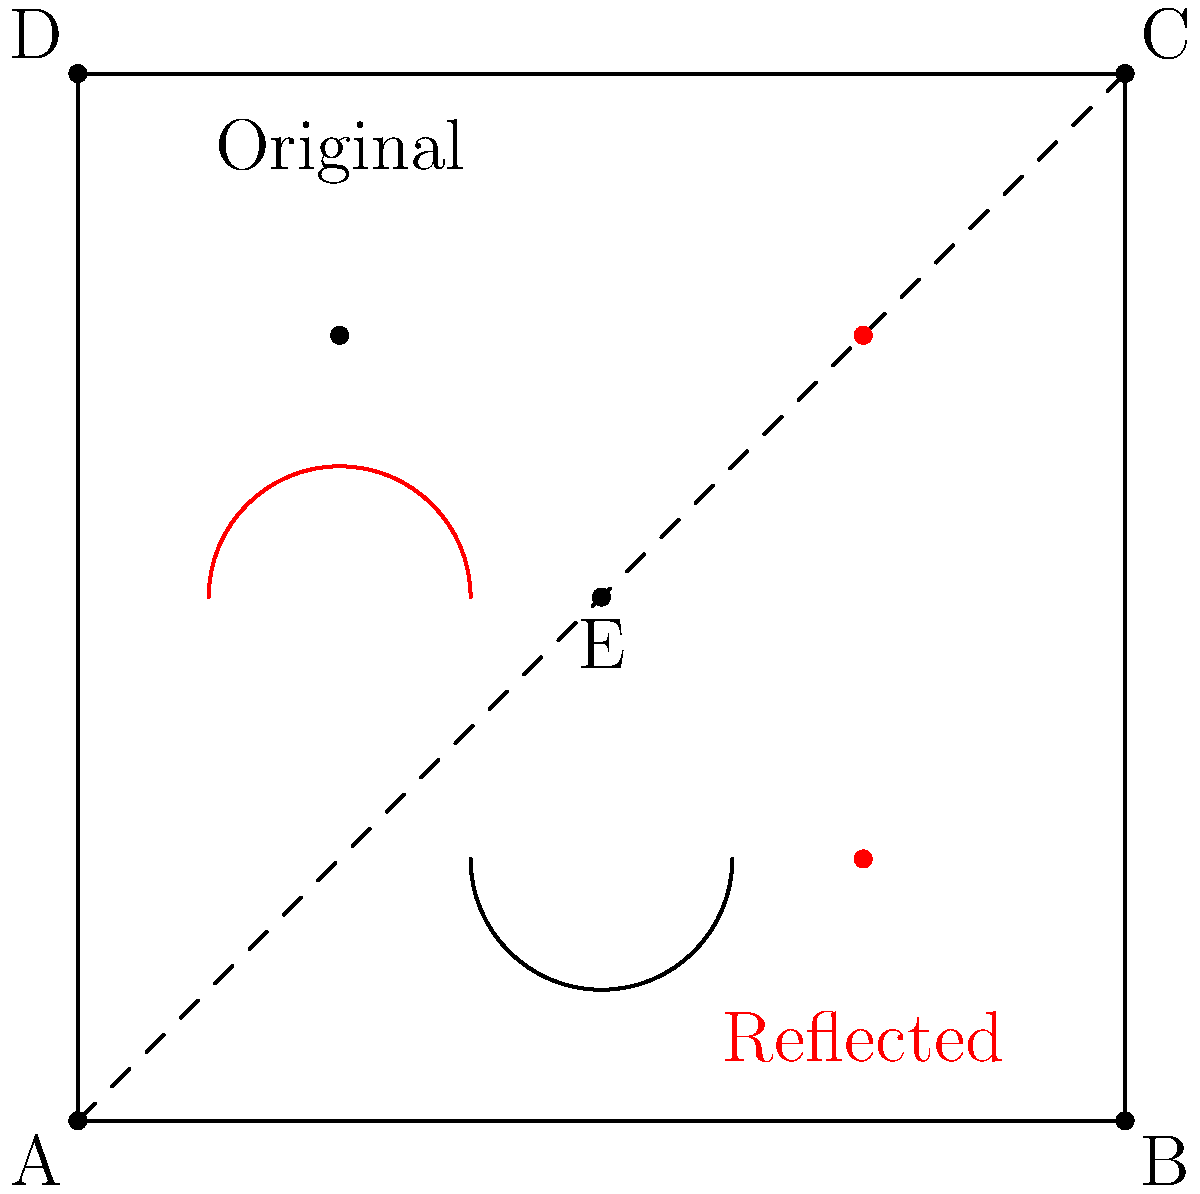Hey Tom! Remember when we used to doodle silly faces in our math notebooks? Let's take it up a notch! I've drawn a smiley face in a square ABCD with side length 4 units. The diagonal AC is the line of reflection. After reflecting the smiley face across AC, what are the coordinates of the reflected right eye (originally at (3,3))? Alright, buddy, let's break this down step-by-step:

1) The line of reflection is the diagonal AC, which goes from (0,0) to (4,4).

2) To reflect a point across a line, we can use the formula:
   $$(x', y') = (x, y) + 2((ax + by + c)/(a^2 + b^2))(-b, a)$$
   where $ax + by + c = 0$ is the equation of the reflection line.

3) For our diagonal AC, we can write the equation as $y = x$ or $x - y = 0$.
   So, $a = 1$, $b = -1$, and $c = 0$.

4) The original right eye is at (3,3). Let's plug this into our formula:
   $x = 3$, $y = 3$
   
   $$(x', y') = (3, 3) + 2((1(3) + (-1)(3) + 0)/(1^2 + (-1)^2))(1, 1)$$

5) Simplify:
   $$(x', y') = (3, 3) + 2((0)/(2))(1, 1) = (3, 3) + (0, 0) = (3, 3)$$

6) Wait a second! The point didn't move? That's because it's already on the line of reflection!

7) But we know from the symmetry of the square that the reflected right eye should be where the original left eye was, at (1,1).

8) We can confirm this by reflecting (1,1) across the diagonal:
   $$(x', y') = (1, 1) + 2((1(1) + (-1)(1) + 0)/(1^2 + (-1)^2))(1, 1)$$
   $$(x', y') = (1, 1) + 2((0)/(2))(1, 1) = (1, 1) + (0, 0) = (1, 1)$$

So, the reflected right eye ends up at (1,1), which matches our intuition!
Answer: (1,1) 